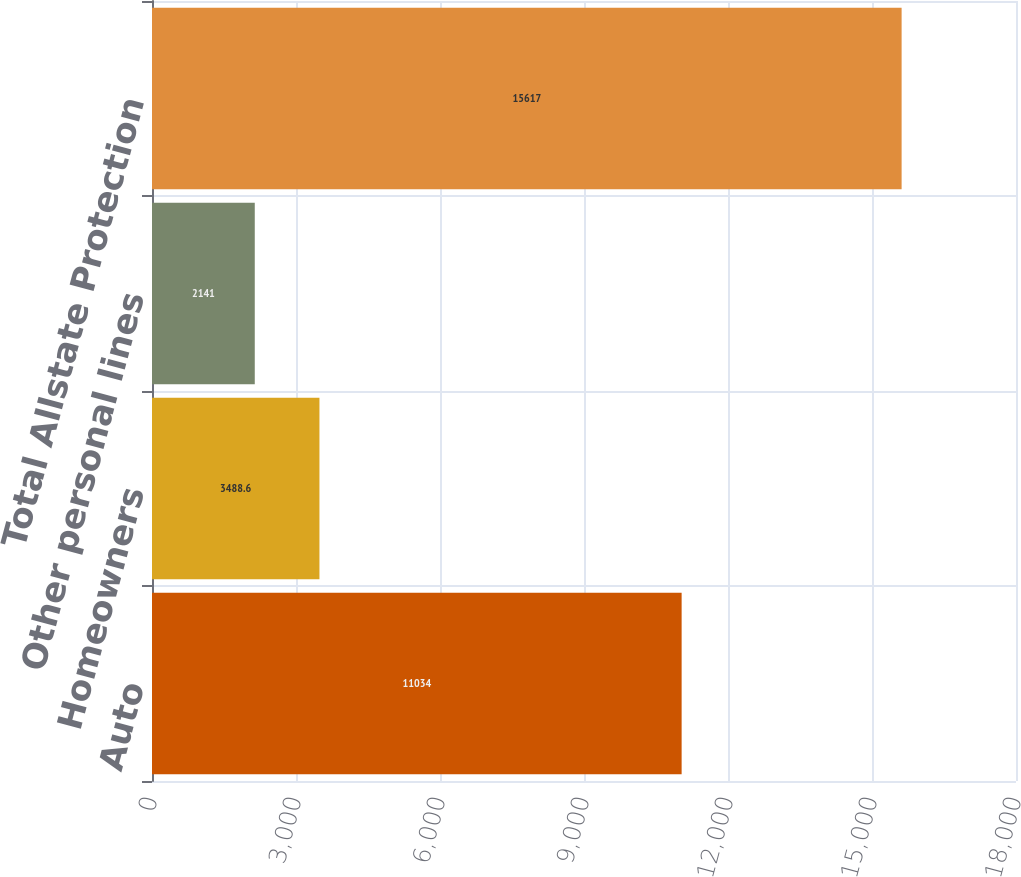Convert chart. <chart><loc_0><loc_0><loc_500><loc_500><bar_chart><fcel>Auto<fcel>Homeowners<fcel>Other personal lines<fcel>Total Allstate Protection<nl><fcel>11034<fcel>3488.6<fcel>2141<fcel>15617<nl></chart> 